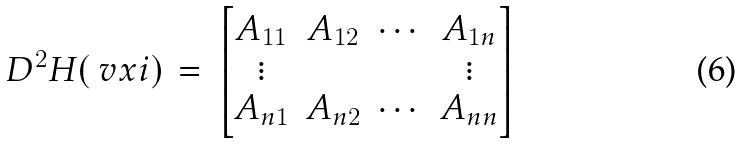<formula> <loc_0><loc_0><loc_500><loc_500>D ^ { 2 } H ( \ v x i ) \, = \, \begin{bmatrix} A _ { 1 1 } & A _ { 1 2 } & \cdots & A _ { 1 n } \\ \vdots & & & \vdots \\ A _ { n 1 } & A _ { n 2 } & \cdots & A _ { n n } \end{bmatrix}</formula> 